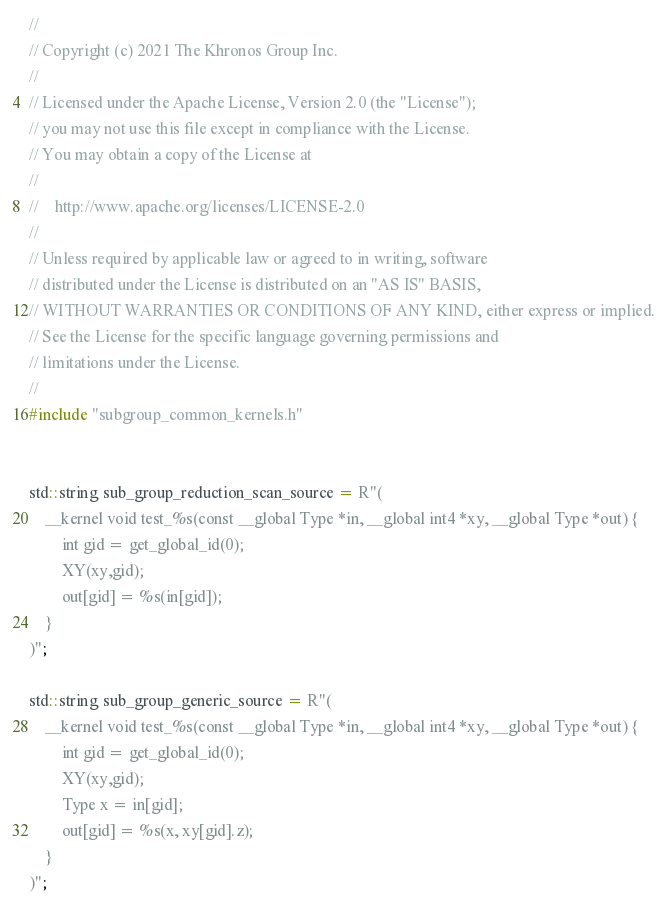Convert code to text. <code><loc_0><loc_0><loc_500><loc_500><_C++_>//
// Copyright (c) 2021 The Khronos Group Inc.
//
// Licensed under the Apache License, Version 2.0 (the "License");
// you may not use this file except in compliance with the License.
// You may obtain a copy of the License at
//
//    http://www.apache.org/licenses/LICENSE-2.0
//
// Unless required by applicable law or agreed to in writing, software
// distributed under the License is distributed on an "AS IS" BASIS,
// WITHOUT WARRANTIES OR CONDITIONS OF ANY KIND, either express or implied.
// See the License for the specific language governing permissions and
// limitations under the License.
//
#include "subgroup_common_kernels.h"


std::string sub_group_reduction_scan_source = R"(
    __kernel void test_%s(const __global Type *in, __global int4 *xy, __global Type *out) {
        int gid = get_global_id(0);
        XY(xy,gid);
        out[gid] = %s(in[gid]);
    }
)";

std::string sub_group_generic_source = R"(
    __kernel void test_%s(const __global Type *in, __global int4 *xy, __global Type *out) {
        int gid = get_global_id(0);
        XY(xy,gid);
        Type x = in[gid];
        out[gid] = %s(x, xy[gid].z);
    }
)";</code> 